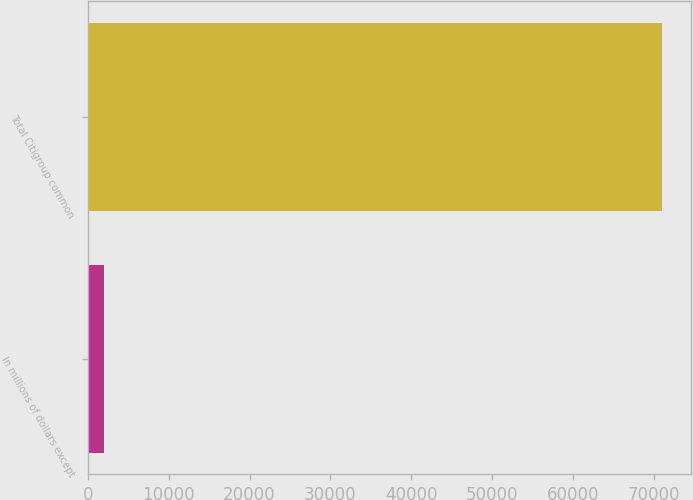Convert chart to OTSL. <chart><loc_0><loc_0><loc_500><loc_500><bar_chart><fcel>In millions of dollars except<fcel>Total Citigroup common<nl><fcel>2008<fcel>70966<nl></chart> 